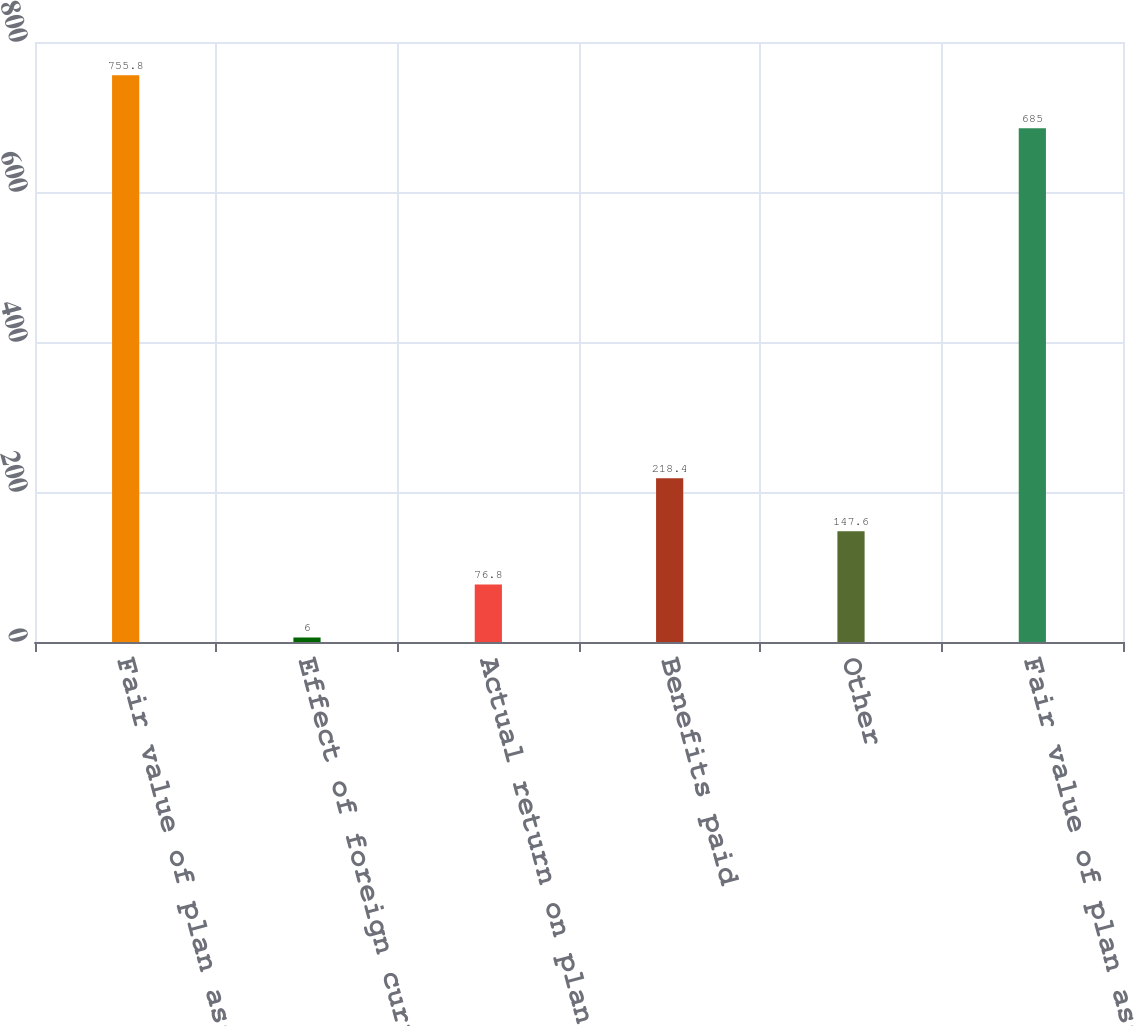Convert chart. <chart><loc_0><loc_0><loc_500><loc_500><bar_chart><fcel>Fair value of plan assets at<fcel>Effect of foreign currency<fcel>Actual return on plan assets<fcel>Benefits paid<fcel>Other<fcel>Fair value of plan assets as<nl><fcel>755.8<fcel>6<fcel>76.8<fcel>218.4<fcel>147.6<fcel>685<nl></chart> 